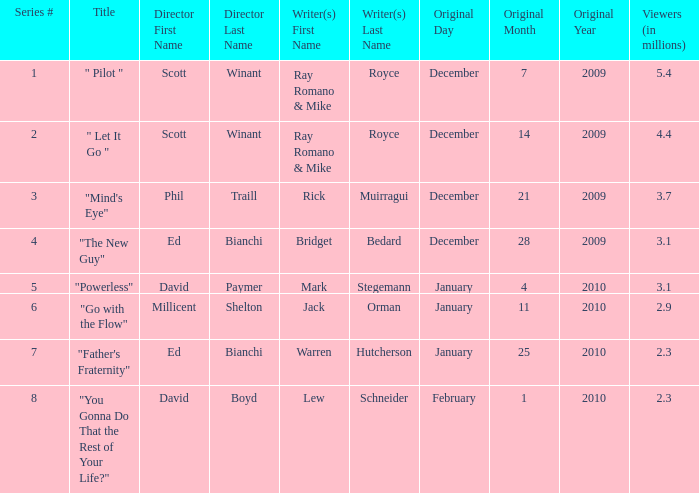How many episodes are written by Lew Schneider? 1.0. 